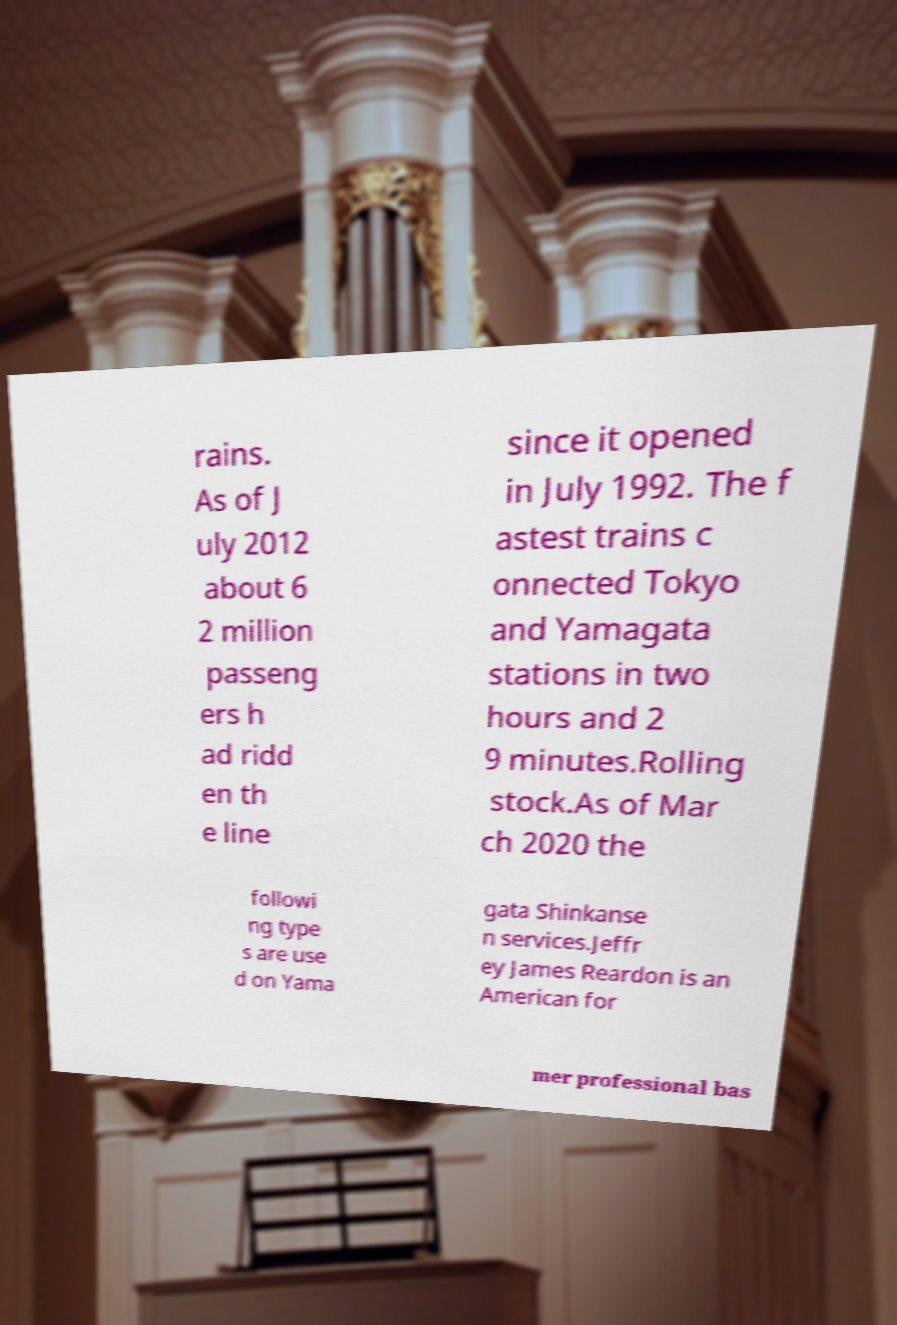Please read and relay the text visible in this image. What does it say? rains. As of J uly 2012 about 6 2 million passeng ers h ad ridd en th e line since it opened in July 1992. The f astest trains c onnected Tokyo and Yamagata stations in two hours and 2 9 minutes.Rolling stock.As of Mar ch 2020 the followi ng type s are use d on Yama gata Shinkanse n services.Jeffr ey James Reardon is an American for mer professional bas 